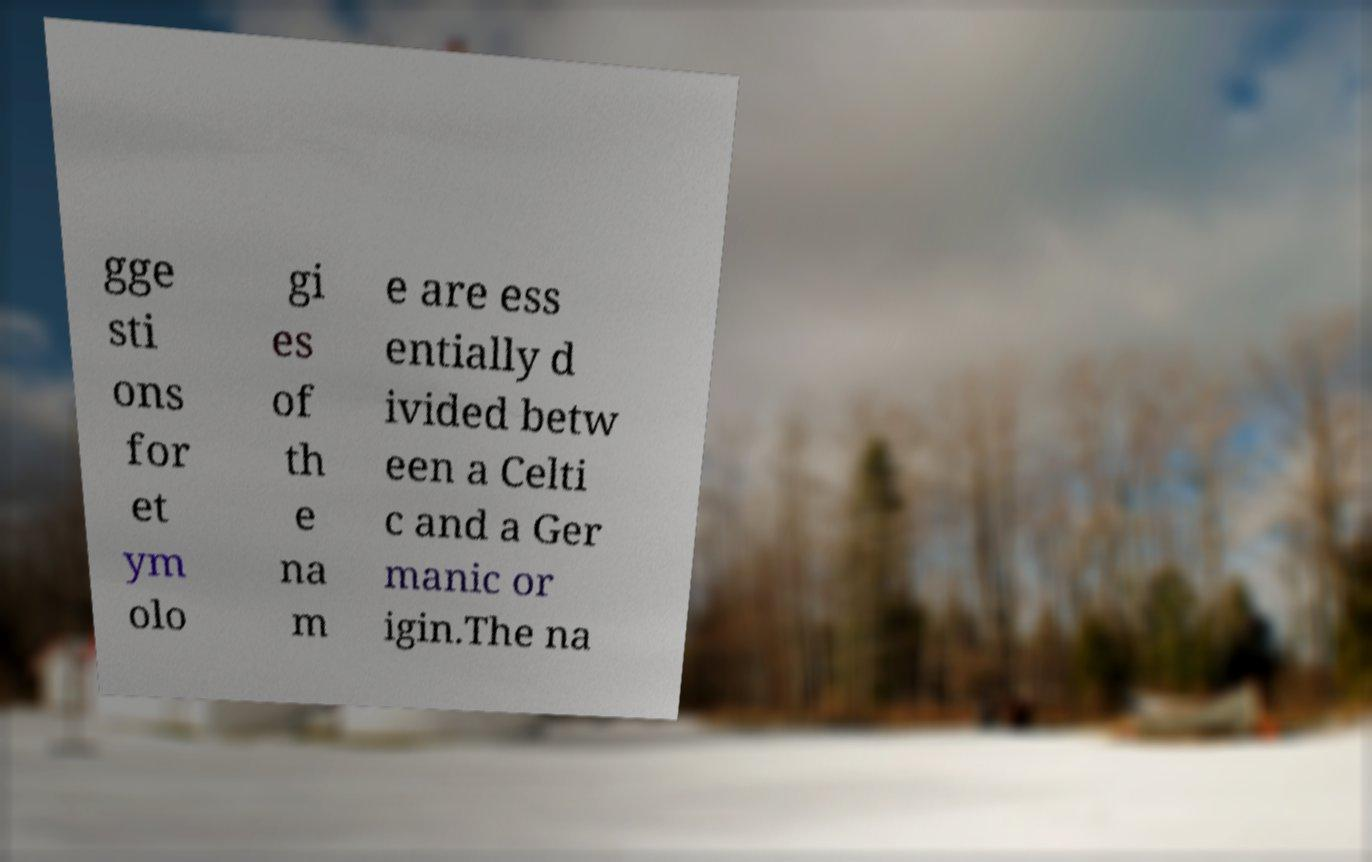Can you read and provide the text displayed in the image?This photo seems to have some interesting text. Can you extract and type it out for me? gge sti ons for et ym olo gi es of th e na m e are ess entially d ivided betw een a Celti c and a Ger manic or igin.The na 